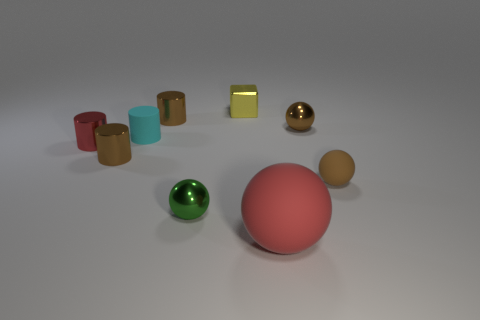Is there anything else that is the same shape as the tiny cyan rubber object?
Make the answer very short. Yes. There is a cube that is made of the same material as the tiny red cylinder; what is its color?
Ensure brevity in your answer.  Yellow. There is a tiny metal cylinder behind the metal thing to the right of the small block; is there a green sphere left of it?
Offer a terse response. No. Are there fewer tiny brown rubber objects behind the tiny yellow object than tiny rubber cylinders in front of the green shiny ball?
Your answer should be compact. No. What number of objects have the same material as the yellow block?
Your response must be concise. 5. Is the size of the yellow cube the same as the cyan rubber cylinder on the left side of the brown matte sphere?
Offer a very short reply. Yes. What material is the small thing that is the same color as the big sphere?
Your answer should be very brief. Metal. How big is the cube behind the tiny rubber ball that is right of the shiny ball that is behind the tiny cyan rubber cylinder?
Provide a short and direct response. Small. Is the number of yellow metal cubes to the right of the big red thing greater than the number of small cyan objects in front of the tiny green shiny thing?
Ensure brevity in your answer.  No. What number of small rubber cylinders are to the right of the small sphere left of the big red ball?
Your response must be concise. 0. 